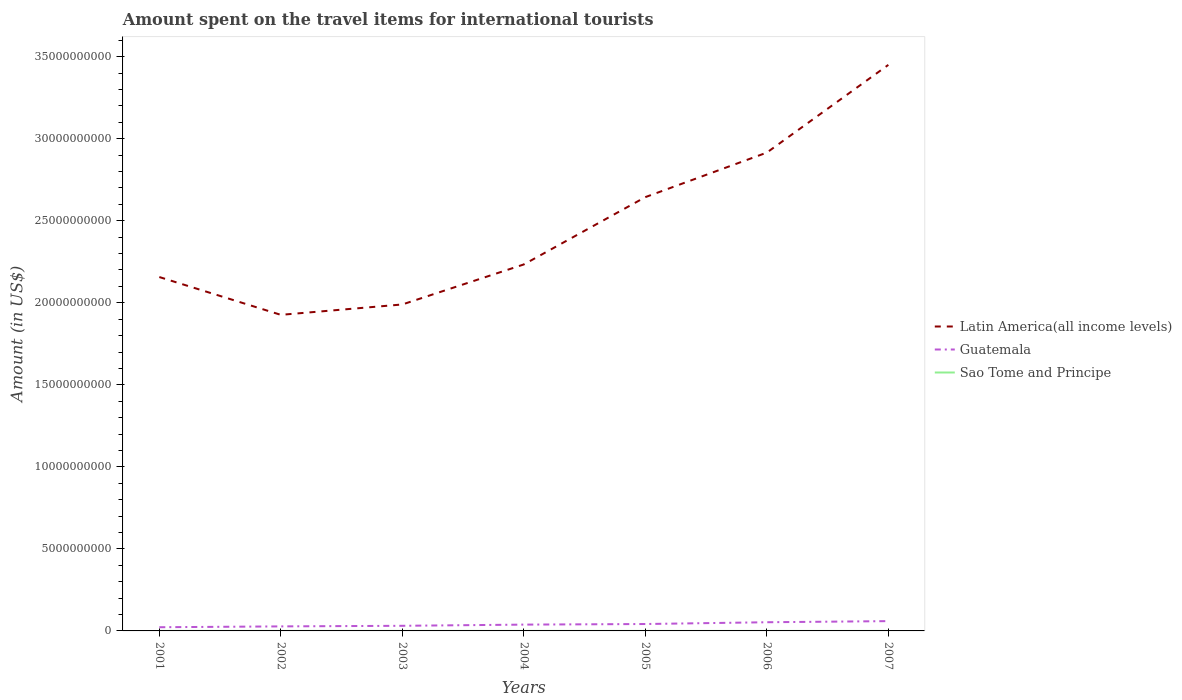Is the number of lines equal to the number of legend labels?
Keep it short and to the point. Yes. Across all years, what is the maximum amount spent on the travel items for international tourists in Latin America(all income levels)?
Your response must be concise. 1.93e+1. In which year was the amount spent on the travel items for international tourists in Guatemala maximum?
Ensure brevity in your answer.  2001. What is the total amount spent on the travel items for international tourists in Latin America(all income levels) in the graph?
Ensure brevity in your answer.  -5.35e+09. What is the difference between the highest and the second highest amount spent on the travel items for international tourists in Latin America(all income levels)?
Provide a short and direct response. 1.52e+1. What is the difference between the highest and the lowest amount spent on the travel items for international tourists in Latin America(all income levels)?
Offer a terse response. 3. How many years are there in the graph?
Offer a terse response. 7. What is the difference between two consecutive major ticks on the Y-axis?
Provide a short and direct response. 5.00e+09. How many legend labels are there?
Give a very brief answer. 3. What is the title of the graph?
Make the answer very short. Amount spent on the travel items for international tourists. What is the label or title of the X-axis?
Keep it short and to the point. Years. What is the Amount (in US$) in Latin America(all income levels) in 2001?
Keep it short and to the point. 2.16e+1. What is the Amount (in US$) of Guatemala in 2001?
Keep it short and to the point. 2.25e+08. What is the Amount (in US$) in Latin America(all income levels) in 2002?
Keep it short and to the point. 1.93e+1. What is the Amount (in US$) of Guatemala in 2002?
Offer a terse response. 2.76e+08. What is the Amount (in US$) of Latin America(all income levels) in 2003?
Provide a short and direct response. 1.99e+1. What is the Amount (in US$) of Guatemala in 2003?
Provide a short and direct response. 3.12e+08. What is the Amount (in US$) of Sao Tome and Principe in 2003?
Offer a very short reply. 5.00e+05. What is the Amount (in US$) in Latin America(all income levels) in 2004?
Provide a succinct answer. 2.23e+1. What is the Amount (in US$) of Guatemala in 2004?
Provide a succinct answer. 3.85e+08. What is the Amount (in US$) of Latin America(all income levels) in 2005?
Offer a very short reply. 2.64e+1. What is the Amount (in US$) in Guatemala in 2005?
Offer a terse response. 4.21e+08. What is the Amount (in US$) of Sao Tome and Principe in 2005?
Your answer should be compact. 5.00e+04. What is the Amount (in US$) of Latin America(all income levels) in 2006?
Give a very brief answer. 2.92e+1. What is the Amount (in US$) in Guatemala in 2006?
Your answer should be very brief. 5.29e+08. What is the Amount (in US$) in Sao Tome and Principe in 2006?
Give a very brief answer. 2.00e+05. What is the Amount (in US$) of Latin America(all income levels) in 2007?
Offer a terse response. 3.45e+1. What is the Amount (in US$) in Guatemala in 2007?
Provide a short and direct response. 5.97e+08. Across all years, what is the maximum Amount (in US$) of Latin America(all income levels)?
Make the answer very short. 3.45e+1. Across all years, what is the maximum Amount (in US$) of Guatemala?
Your answer should be very brief. 5.97e+08. Across all years, what is the minimum Amount (in US$) of Latin America(all income levels)?
Provide a short and direct response. 1.93e+1. Across all years, what is the minimum Amount (in US$) of Guatemala?
Your response must be concise. 2.25e+08. Across all years, what is the minimum Amount (in US$) of Sao Tome and Principe?
Offer a very short reply. 5.00e+04. What is the total Amount (in US$) in Latin America(all income levels) in the graph?
Ensure brevity in your answer.  1.73e+11. What is the total Amount (in US$) of Guatemala in the graph?
Provide a short and direct response. 2.74e+09. What is the total Amount (in US$) of Sao Tome and Principe in the graph?
Keep it short and to the point. 2.55e+06. What is the difference between the Amount (in US$) of Latin America(all income levels) in 2001 and that in 2002?
Ensure brevity in your answer.  2.30e+09. What is the difference between the Amount (in US$) of Guatemala in 2001 and that in 2002?
Your response must be concise. -5.10e+07. What is the difference between the Amount (in US$) in Latin America(all income levels) in 2001 and that in 2003?
Your response must be concise. 1.67e+09. What is the difference between the Amount (in US$) of Guatemala in 2001 and that in 2003?
Your answer should be compact. -8.70e+07. What is the difference between the Amount (in US$) of Sao Tome and Principe in 2001 and that in 2003?
Ensure brevity in your answer.  1.00e+05. What is the difference between the Amount (in US$) of Latin America(all income levels) in 2001 and that in 2004?
Provide a short and direct response. -7.68e+08. What is the difference between the Amount (in US$) in Guatemala in 2001 and that in 2004?
Make the answer very short. -1.60e+08. What is the difference between the Amount (in US$) of Sao Tome and Principe in 2001 and that in 2004?
Ensure brevity in your answer.  0. What is the difference between the Amount (in US$) in Latin America(all income levels) in 2001 and that in 2005?
Make the answer very short. -4.87e+09. What is the difference between the Amount (in US$) in Guatemala in 2001 and that in 2005?
Ensure brevity in your answer.  -1.96e+08. What is the difference between the Amount (in US$) in Sao Tome and Principe in 2001 and that in 2005?
Your answer should be very brief. 5.50e+05. What is the difference between the Amount (in US$) of Latin America(all income levels) in 2001 and that in 2006?
Provide a succinct answer. -7.59e+09. What is the difference between the Amount (in US$) in Guatemala in 2001 and that in 2006?
Your answer should be compact. -3.04e+08. What is the difference between the Amount (in US$) of Latin America(all income levels) in 2001 and that in 2007?
Your answer should be very brief. -1.29e+1. What is the difference between the Amount (in US$) in Guatemala in 2001 and that in 2007?
Give a very brief answer. -3.72e+08. What is the difference between the Amount (in US$) of Sao Tome and Principe in 2001 and that in 2007?
Offer a terse response. 5.00e+05. What is the difference between the Amount (in US$) of Latin America(all income levels) in 2002 and that in 2003?
Your answer should be compact. -6.33e+08. What is the difference between the Amount (in US$) in Guatemala in 2002 and that in 2003?
Ensure brevity in your answer.  -3.60e+07. What is the difference between the Amount (in US$) of Latin America(all income levels) in 2002 and that in 2004?
Offer a terse response. -3.07e+09. What is the difference between the Amount (in US$) in Guatemala in 2002 and that in 2004?
Offer a very short reply. -1.09e+08. What is the difference between the Amount (in US$) in Sao Tome and Principe in 2002 and that in 2004?
Your answer should be very brief. -1.00e+05. What is the difference between the Amount (in US$) of Latin America(all income levels) in 2002 and that in 2005?
Give a very brief answer. -7.17e+09. What is the difference between the Amount (in US$) in Guatemala in 2002 and that in 2005?
Make the answer very short. -1.45e+08. What is the difference between the Amount (in US$) in Sao Tome and Principe in 2002 and that in 2005?
Your answer should be compact. 4.50e+05. What is the difference between the Amount (in US$) of Latin America(all income levels) in 2002 and that in 2006?
Provide a short and direct response. -9.89e+09. What is the difference between the Amount (in US$) in Guatemala in 2002 and that in 2006?
Your answer should be compact. -2.53e+08. What is the difference between the Amount (in US$) in Latin America(all income levels) in 2002 and that in 2007?
Make the answer very short. -1.52e+1. What is the difference between the Amount (in US$) in Guatemala in 2002 and that in 2007?
Make the answer very short. -3.21e+08. What is the difference between the Amount (in US$) in Latin America(all income levels) in 2003 and that in 2004?
Offer a very short reply. -2.44e+09. What is the difference between the Amount (in US$) of Guatemala in 2003 and that in 2004?
Give a very brief answer. -7.30e+07. What is the difference between the Amount (in US$) of Latin America(all income levels) in 2003 and that in 2005?
Ensure brevity in your answer.  -6.54e+09. What is the difference between the Amount (in US$) in Guatemala in 2003 and that in 2005?
Your response must be concise. -1.09e+08. What is the difference between the Amount (in US$) of Latin America(all income levels) in 2003 and that in 2006?
Give a very brief answer. -9.26e+09. What is the difference between the Amount (in US$) in Guatemala in 2003 and that in 2006?
Provide a short and direct response. -2.17e+08. What is the difference between the Amount (in US$) in Sao Tome and Principe in 2003 and that in 2006?
Ensure brevity in your answer.  3.00e+05. What is the difference between the Amount (in US$) in Latin America(all income levels) in 2003 and that in 2007?
Keep it short and to the point. -1.46e+1. What is the difference between the Amount (in US$) of Guatemala in 2003 and that in 2007?
Provide a short and direct response. -2.85e+08. What is the difference between the Amount (in US$) of Sao Tome and Principe in 2003 and that in 2007?
Keep it short and to the point. 4.00e+05. What is the difference between the Amount (in US$) in Latin America(all income levels) in 2004 and that in 2005?
Ensure brevity in your answer.  -4.10e+09. What is the difference between the Amount (in US$) of Guatemala in 2004 and that in 2005?
Give a very brief answer. -3.60e+07. What is the difference between the Amount (in US$) of Sao Tome and Principe in 2004 and that in 2005?
Ensure brevity in your answer.  5.50e+05. What is the difference between the Amount (in US$) of Latin America(all income levels) in 2004 and that in 2006?
Provide a succinct answer. -6.82e+09. What is the difference between the Amount (in US$) in Guatemala in 2004 and that in 2006?
Your response must be concise. -1.44e+08. What is the difference between the Amount (in US$) of Sao Tome and Principe in 2004 and that in 2006?
Keep it short and to the point. 4.00e+05. What is the difference between the Amount (in US$) of Latin America(all income levels) in 2004 and that in 2007?
Your response must be concise. -1.22e+1. What is the difference between the Amount (in US$) in Guatemala in 2004 and that in 2007?
Your answer should be very brief. -2.12e+08. What is the difference between the Amount (in US$) in Latin America(all income levels) in 2005 and that in 2006?
Your answer should be very brief. -2.71e+09. What is the difference between the Amount (in US$) in Guatemala in 2005 and that in 2006?
Provide a succinct answer. -1.08e+08. What is the difference between the Amount (in US$) of Sao Tome and Principe in 2005 and that in 2006?
Provide a short and direct response. -1.50e+05. What is the difference between the Amount (in US$) of Latin America(all income levels) in 2005 and that in 2007?
Your answer should be very brief. -8.06e+09. What is the difference between the Amount (in US$) in Guatemala in 2005 and that in 2007?
Offer a terse response. -1.76e+08. What is the difference between the Amount (in US$) in Latin America(all income levels) in 2006 and that in 2007?
Ensure brevity in your answer.  -5.35e+09. What is the difference between the Amount (in US$) of Guatemala in 2006 and that in 2007?
Make the answer very short. -6.80e+07. What is the difference between the Amount (in US$) in Latin America(all income levels) in 2001 and the Amount (in US$) in Guatemala in 2002?
Offer a terse response. 2.13e+1. What is the difference between the Amount (in US$) in Latin America(all income levels) in 2001 and the Amount (in US$) in Sao Tome and Principe in 2002?
Keep it short and to the point. 2.16e+1. What is the difference between the Amount (in US$) of Guatemala in 2001 and the Amount (in US$) of Sao Tome and Principe in 2002?
Keep it short and to the point. 2.24e+08. What is the difference between the Amount (in US$) in Latin America(all income levels) in 2001 and the Amount (in US$) in Guatemala in 2003?
Provide a short and direct response. 2.13e+1. What is the difference between the Amount (in US$) of Latin America(all income levels) in 2001 and the Amount (in US$) of Sao Tome and Principe in 2003?
Make the answer very short. 2.16e+1. What is the difference between the Amount (in US$) in Guatemala in 2001 and the Amount (in US$) in Sao Tome and Principe in 2003?
Ensure brevity in your answer.  2.24e+08. What is the difference between the Amount (in US$) of Latin America(all income levels) in 2001 and the Amount (in US$) of Guatemala in 2004?
Your response must be concise. 2.12e+1. What is the difference between the Amount (in US$) in Latin America(all income levels) in 2001 and the Amount (in US$) in Sao Tome and Principe in 2004?
Ensure brevity in your answer.  2.16e+1. What is the difference between the Amount (in US$) in Guatemala in 2001 and the Amount (in US$) in Sao Tome and Principe in 2004?
Keep it short and to the point. 2.24e+08. What is the difference between the Amount (in US$) of Latin America(all income levels) in 2001 and the Amount (in US$) of Guatemala in 2005?
Give a very brief answer. 2.11e+1. What is the difference between the Amount (in US$) in Latin America(all income levels) in 2001 and the Amount (in US$) in Sao Tome and Principe in 2005?
Offer a very short reply. 2.16e+1. What is the difference between the Amount (in US$) in Guatemala in 2001 and the Amount (in US$) in Sao Tome and Principe in 2005?
Your response must be concise. 2.25e+08. What is the difference between the Amount (in US$) in Latin America(all income levels) in 2001 and the Amount (in US$) in Guatemala in 2006?
Keep it short and to the point. 2.10e+1. What is the difference between the Amount (in US$) in Latin America(all income levels) in 2001 and the Amount (in US$) in Sao Tome and Principe in 2006?
Make the answer very short. 2.16e+1. What is the difference between the Amount (in US$) of Guatemala in 2001 and the Amount (in US$) of Sao Tome and Principe in 2006?
Provide a short and direct response. 2.25e+08. What is the difference between the Amount (in US$) of Latin America(all income levels) in 2001 and the Amount (in US$) of Guatemala in 2007?
Keep it short and to the point. 2.10e+1. What is the difference between the Amount (in US$) of Latin America(all income levels) in 2001 and the Amount (in US$) of Sao Tome and Principe in 2007?
Provide a succinct answer. 2.16e+1. What is the difference between the Amount (in US$) in Guatemala in 2001 and the Amount (in US$) in Sao Tome and Principe in 2007?
Offer a very short reply. 2.25e+08. What is the difference between the Amount (in US$) of Latin America(all income levels) in 2002 and the Amount (in US$) of Guatemala in 2003?
Provide a short and direct response. 1.90e+1. What is the difference between the Amount (in US$) in Latin America(all income levels) in 2002 and the Amount (in US$) in Sao Tome and Principe in 2003?
Keep it short and to the point. 1.93e+1. What is the difference between the Amount (in US$) of Guatemala in 2002 and the Amount (in US$) of Sao Tome and Principe in 2003?
Your answer should be very brief. 2.76e+08. What is the difference between the Amount (in US$) in Latin America(all income levels) in 2002 and the Amount (in US$) in Guatemala in 2004?
Keep it short and to the point. 1.89e+1. What is the difference between the Amount (in US$) of Latin America(all income levels) in 2002 and the Amount (in US$) of Sao Tome and Principe in 2004?
Give a very brief answer. 1.93e+1. What is the difference between the Amount (in US$) of Guatemala in 2002 and the Amount (in US$) of Sao Tome and Principe in 2004?
Offer a very short reply. 2.75e+08. What is the difference between the Amount (in US$) of Latin America(all income levels) in 2002 and the Amount (in US$) of Guatemala in 2005?
Ensure brevity in your answer.  1.88e+1. What is the difference between the Amount (in US$) in Latin America(all income levels) in 2002 and the Amount (in US$) in Sao Tome and Principe in 2005?
Your answer should be very brief. 1.93e+1. What is the difference between the Amount (in US$) in Guatemala in 2002 and the Amount (in US$) in Sao Tome and Principe in 2005?
Offer a very short reply. 2.76e+08. What is the difference between the Amount (in US$) in Latin America(all income levels) in 2002 and the Amount (in US$) in Guatemala in 2006?
Offer a very short reply. 1.87e+1. What is the difference between the Amount (in US$) of Latin America(all income levels) in 2002 and the Amount (in US$) of Sao Tome and Principe in 2006?
Ensure brevity in your answer.  1.93e+1. What is the difference between the Amount (in US$) of Guatemala in 2002 and the Amount (in US$) of Sao Tome and Principe in 2006?
Offer a very short reply. 2.76e+08. What is the difference between the Amount (in US$) of Latin America(all income levels) in 2002 and the Amount (in US$) of Guatemala in 2007?
Ensure brevity in your answer.  1.87e+1. What is the difference between the Amount (in US$) of Latin America(all income levels) in 2002 and the Amount (in US$) of Sao Tome and Principe in 2007?
Ensure brevity in your answer.  1.93e+1. What is the difference between the Amount (in US$) in Guatemala in 2002 and the Amount (in US$) in Sao Tome and Principe in 2007?
Make the answer very short. 2.76e+08. What is the difference between the Amount (in US$) of Latin America(all income levels) in 2003 and the Amount (in US$) of Guatemala in 2004?
Provide a succinct answer. 1.95e+1. What is the difference between the Amount (in US$) in Latin America(all income levels) in 2003 and the Amount (in US$) in Sao Tome and Principe in 2004?
Keep it short and to the point. 1.99e+1. What is the difference between the Amount (in US$) of Guatemala in 2003 and the Amount (in US$) of Sao Tome and Principe in 2004?
Provide a succinct answer. 3.11e+08. What is the difference between the Amount (in US$) of Latin America(all income levels) in 2003 and the Amount (in US$) of Guatemala in 2005?
Ensure brevity in your answer.  1.95e+1. What is the difference between the Amount (in US$) in Latin America(all income levels) in 2003 and the Amount (in US$) in Sao Tome and Principe in 2005?
Ensure brevity in your answer.  1.99e+1. What is the difference between the Amount (in US$) in Guatemala in 2003 and the Amount (in US$) in Sao Tome and Principe in 2005?
Ensure brevity in your answer.  3.12e+08. What is the difference between the Amount (in US$) of Latin America(all income levels) in 2003 and the Amount (in US$) of Guatemala in 2006?
Ensure brevity in your answer.  1.94e+1. What is the difference between the Amount (in US$) of Latin America(all income levels) in 2003 and the Amount (in US$) of Sao Tome and Principe in 2006?
Ensure brevity in your answer.  1.99e+1. What is the difference between the Amount (in US$) in Guatemala in 2003 and the Amount (in US$) in Sao Tome and Principe in 2006?
Make the answer very short. 3.12e+08. What is the difference between the Amount (in US$) of Latin America(all income levels) in 2003 and the Amount (in US$) of Guatemala in 2007?
Provide a succinct answer. 1.93e+1. What is the difference between the Amount (in US$) of Latin America(all income levels) in 2003 and the Amount (in US$) of Sao Tome and Principe in 2007?
Make the answer very short. 1.99e+1. What is the difference between the Amount (in US$) in Guatemala in 2003 and the Amount (in US$) in Sao Tome and Principe in 2007?
Keep it short and to the point. 3.12e+08. What is the difference between the Amount (in US$) of Latin America(all income levels) in 2004 and the Amount (in US$) of Guatemala in 2005?
Make the answer very short. 2.19e+1. What is the difference between the Amount (in US$) in Latin America(all income levels) in 2004 and the Amount (in US$) in Sao Tome and Principe in 2005?
Offer a very short reply. 2.23e+1. What is the difference between the Amount (in US$) in Guatemala in 2004 and the Amount (in US$) in Sao Tome and Principe in 2005?
Your answer should be compact. 3.85e+08. What is the difference between the Amount (in US$) in Latin America(all income levels) in 2004 and the Amount (in US$) in Guatemala in 2006?
Make the answer very short. 2.18e+1. What is the difference between the Amount (in US$) of Latin America(all income levels) in 2004 and the Amount (in US$) of Sao Tome and Principe in 2006?
Offer a terse response. 2.23e+1. What is the difference between the Amount (in US$) in Guatemala in 2004 and the Amount (in US$) in Sao Tome and Principe in 2006?
Your answer should be compact. 3.85e+08. What is the difference between the Amount (in US$) in Latin America(all income levels) in 2004 and the Amount (in US$) in Guatemala in 2007?
Keep it short and to the point. 2.17e+1. What is the difference between the Amount (in US$) of Latin America(all income levels) in 2004 and the Amount (in US$) of Sao Tome and Principe in 2007?
Make the answer very short. 2.23e+1. What is the difference between the Amount (in US$) in Guatemala in 2004 and the Amount (in US$) in Sao Tome and Principe in 2007?
Keep it short and to the point. 3.85e+08. What is the difference between the Amount (in US$) in Latin America(all income levels) in 2005 and the Amount (in US$) in Guatemala in 2006?
Your answer should be compact. 2.59e+1. What is the difference between the Amount (in US$) of Latin America(all income levels) in 2005 and the Amount (in US$) of Sao Tome and Principe in 2006?
Provide a succinct answer. 2.64e+1. What is the difference between the Amount (in US$) of Guatemala in 2005 and the Amount (in US$) of Sao Tome and Principe in 2006?
Ensure brevity in your answer.  4.21e+08. What is the difference between the Amount (in US$) of Latin America(all income levels) in 2005 and the Amount (in US$) of Guatemala in 2007?
Your response must be concise. 2.58e+1. What is the difference between the Amount (in US$) in Latin America(all income levels) in 2005 and the Amount (in US$) in Sao Tome and Principe in 2007?
Your answer should be very brief. 2.64e+1. What is the difference between the Amount (in US$) of Guatemala in 2005 and the Amount (in US$) of Sao Tome and Principe in 2007?
Make the answer very short. 4.21e+08. What is the difference between the Amount (in US$) in Latin America(all income levels) in 2006 and the Amount (in US$) in Guatemala in 2007?
Provide a succinct answer. 2.86e+1. What is the difference between the Amount (in US$) in Latin America(all income levels) in 2006 and the Amount (in US$) in Sao Tome and Principe in 2007?
Keep it short and to the point. 2.92e+1. What is the difference between the Amount (in US$) in Guatemala in 2006 and the Amount (in US$) in Sao Tome and Principe in 2007?
Provide a succinct answer. 5.29e+08. What is the average Amount (in US$) in Latin America(all income levels) per year?
Offer a terse response. 2.47e+1. What is the average Amount (in US$) of Guatemala per year?
Offer a terse response. 3.92e+08. What is the average Amount (in US$) of Sao Tome and Principe per year?
Your response must be concise. 3.64e+05. In the year 2001, what is the difference between the Amount (in US$) of Latin America(all income levels) and Amount (in US$) of Guatemala?
Make the answer very short. 2.13e+1. In the year 2001, what is the difference between the Amount (in US$) of Latin America(all income levels) and Amount (in US$) of Sao Tome and Principe?
Give a very brief answer. 2.16e+1. In the year 2001, what is the difference between the Amount (in US$) of Guatemala and Amount (in US$) of Sao Tome and Principe?
Your answer should be compact. 2.24e+08. In the year 2002, what is the difference between the Amount (in US$) of Latin America(all income levels) and Amount (in US$) of Guatemala?
Keep it short and to the point. 1.90e+1. In the year 2002, what is the difference between the Amount (in US$) in Latin America(all income levels) and Amount (in US$) in Sao Tome and Principe?
Your response must be concise. 1.93e+1. In the year 2002, what is the difference between the Amount (in US$) in Guatemala and Amount (in US$) in Sao Tome and Principe?
Offer a very short reply. 2.76e+08. In the year 2003, what is the difference between the Amount (in US$) in Latin America(all income levels) and Amount (in US$) in Guatemala?
Your answer should be very brief. 1.96e+1. In the year 2003, what is the difference between the Amount (in US$) of Latin America(all income levels) and Amount (in US$) of Sao Tome and Principe?
Ensure brevity in your answer.  1.99e+1. In the year 2003, what is the difference between the Amount (in US$) of Guatemala and Amount (in US$) of Sao Tome and Principe?
Your answer should be compact. 3.12e+08. In the year 2004, what is the difference between the Amount (in US$) in Latin America(all income levels) and Amount (in US$) in Guatemala?
Give a very brief answer. 2.20e+1. In the year 2004, what is the difference between the Amount (in US$) in Latin America(all income levels) and Amount (in US$) in Sao Tome and Principe?
Give a very brief answer. 2.23e+1. In the year 2004, what is the difference between the Amount (in US$) of Guatemala and Amount (in US$) of Sao Tome and Principe?
Your response must be concise. 3.84e+08. In the year 2005, what is the difference between the Amount (in US$) in Latin America(all income levels) and Amount (in US$) in Guatemala?
Make the answer very short. 2.60e+1. In the year 2005, what is the difference between the Amount (in US$) of Latin America(all income levels) and Amount (in US$) of Sao Tome and Principe?
Keep it short and to the point. 2.64e+1. In the year 2005, what is the difference between the Amount (in US$) in Guatemala and Amount (in US$) in Sao Tome and Principe?
Give a very brief answer. 4.21e+08. In the year 2006, what is the difference between the Amount (in US$) in Latin America(all income levels) and Amount (in US$) in Guatemala?
Give a very brief answer. 2.86e+1. In the year 2006, what is the difference between the Amount (in US$) in Latin America(all income levels) and Amount (in US$) in Sao Tome and Principe?
Your answer should be compact. 2.92e+1. In the year 2006, what is the difference between the Amount (in US$) of Guatemala and Amount (in US$) of Sao Tome and Principe?
Your answer should be compact. 5.29e+08. In the year 2007, what is the difference between the Amount (in US$) of Latin America(all income levels) and Amount (in US$) of Guatemala?
Give a very brief answer. 3.39e+1. In the year 2007, what is the difference between the Amount (in US$) in Latin America(all income levels) and Amount (in US$) in Sao Tome and Principe?
Provide a short and direct response. 3.45e+1. In the year 2007, what is the difference between the Amount (in US$) in Guatemala and Amount (in US$) in Sao Tome and Principe?
Give a very brief answer. 5.97e+08. What is the ratio of the Amount (in US$) of Latin America(all income levels) in 2001 to that in 2002?
Offer a terse response. 1.12. What is the ratio of the Amount (in US$) in Guatemala in 2001 to that in 2002?
Keep it short and to the point. 0.82. What is the ratio of the Amount (in US$) in Latin America(all income levels) in 2001 to that in 2003?
Ensure brevity in your answer.  1.08. What is the ratio of the Amount (in US$) of Guatemala in 2001 to that in 2003?
Your answer should be compact. 0.72. What is the ratio of the Amount (in US$) of Latin America(all income levels) in 2001 to that in 2004?
Your answer should be compact. 0.97. What is the ratio of the Amount (in US$) of Guatemala in 2001 to that in 2004?
Your response must be concise. 0.58. What is the ratio of the Amount (in US$) in Latin America(all income levels) in 2001 to that in 2005?
Your answer should be compact. 0.82. What is the ratio of the Amount (in US$) in Guatemala in 2001 to that in 2005?
Give a very brief answer. 0.53. What is the ratio of the Amount (in US$) in Sao Tome and Principe in 2001 to that in 2005?
Your answer should be very brief. 12. What is the ratio of the Amount (in US$) of Latin America(all income levels) in 2001 to that in 2006?
Make the answer very short. 0.74. What is the ratio of the Amount (in US$) of Guatemala in 2001 to that in 2006?
Your response must be concise. 0.43. What is the ratio of the Amount (in US$) in Sao Tome and Principe in 2001 to that in 2006?
Your answer should be very brief. 3. What is the ratio of the Amount (in US$) of Latin America(all income levels) in 2001 to that in 2007?
Your answer should be compact. 0.63. What is the ratio of the Amount (in US$) of Guatemala in 2001 to that in 2007?
Provide a succinct answer. 0.38. What is the ratio of the Amount (in US$) of Latin America(all income levels) in 2002 to that in 2003?
Your answer should be compact. 0.97. What is the ratio of the Amount (in US$) of Guatemala in 2002 to that in 2003?
Ensure brevity in your answer.  0.88. What is the ratio of the Amount (in US$) in Sao Tome and Principe in 2002 to that in 2003?
Your answer should be compact. 1. What is the ratio of the Amount (in US$) in Latin America(all income levels) in 2002 to that in 2004?
Ensure brevity in your answer.  0.86. What is the ratio of the Amount (in US$) of Guatemala in 2002 to that in 2004?
Your answer should be compact. 0.72. What is the ratio of the Amount (in US$) of Sao Tome and Principe in 2002 to that in 2004?
Ensure brevity in your answer.  0.83. What is the ratio of the Amount (in US$) of Latin America(all income levels) in 2002 to that in 2005?
Offer a terse response. 0.73. What is the ratio of the Amount (in US$) of Guatemala in 2002 to that in 2005?
Your response must be concise. 0.66. What is the ratio of the Amount (in US$) in Sao Tome and Principe in 2002 to that in 2005?
Provide a short and direct response. 10. What is the ratio of the Amount (in US$) in Latin America(all income levels) in 2002 to that in 2006?
Give a very brief answer. 0.66. What is the ratio of the Amount (in US$) in Guatemala in 2002 to that in 2006?
Give a very brief answer. 0.52. What is the ratio of the Amount (in US$) in Sao Tome and Principe in 2002 to that in 2006?
Your answer should be compact. 2.5. What is the ratio of the Amount (in US$) in Latin America(all income levels) in 2002 to that in 2007?
Provide a succinct answer. 0.56. What is the ratio of the Amount (in US$) in Guatemala in 2002 to that in 2007?
Provide a short and direct response. 0.46. What is the ratio of the Amount (in US$) in Latin America(all income levels) in 2003 to that in 2004?
Give a very brief answer. 0.89. What is the ratio of the Amount (in US$) of Guatemala in 2003 to that in 2004?
Keep it short and to the point. 0.81. What is the ratio of the Amount (in US$) of Latin America(all income levels) in 2003 to that in 2005?
Give a very brief answer. 0.75. What is the ratio of the Amount (in US$) in Guatemala in 2003 to that in 2005?
Your answer should be compact. 0.74. What is the ratio of the Amount (in US$) in Sao Tome and Principe in 2003 to that in 2005?
Make the answer very short. 10. What is the ratio of the Amount (in US$) of Latin America(all income levels) in 2003 to that in 2006?
Make the answer very short. 0.68. What is the ratio of the Amount (in US$) in Guatemala in 2003 to that in 2006?
Your answer should be very brief. 0.59. What is the ratio of the Amount (in US$) in Latin America(all income levels) in 2003 to that in 2007?
Your response must be concise. 0.58. What is the ratio of the Amount (in US$) of Guatemala in 2003 to that in 2007?
Your answer should be compact. 0.52. What is the ratio of the Amount (in US$) in Latin America(all income levels) in 2004 to that in 2005?
Provide a succinct answer. 0.84. What is the ratio of the Amount (in US$) in Guatemala in 2004 to that in 2005?
Your answer should be very brief. 0.91. What is the ratio of the Amount (in US$) in Latin America(all income levels) in 2004 to that in 2006?
Provide a short and direct response. 0.77. What is the ratio of the Amount (in US$) of Guatemala in 2004 to that in 2006?
Keep it short and to the point. 0.73. What is the ratio of the Amount (in US$) of Latin America(all income levels) in 2004 to that in 2007?
Your answer should be compact. 0.65. What is the ratio of the Amount (in US$) of Guatemala in 2004 to that in 2007?
Your response must be concise. 0.64. What is the ratio of the Amount (in US$) of Latin America(all income levels) in 2005 to that in 2006?
Your answer should be very brief. 0.91. What is the ratio of the Amount (in US$) of Guatemala in 2005 to that in 2006?
Your answer should be very brief. 0.8. What is the ratio of the Amount (in US$) of Latin America(all income levels) in 2005 to that in 2007?
Keep it short and to the point. 0.77. What is the ratio of the Amount (in US$) in Guatemala in 2005 to that in 2007?
Make the answer very short. 0.71. What is the ratio of the Amount (in US$) of Latin America(all income levels) in 2006 to that in 2007?
Your answer should be compact. 0.84. What is the ratio of the Amount (in US$) in Guatemala in 2006 to that in 2007?
Offer a very short reply. 0.89. What is the ratio of the Amount (in US$) in Sao Tome and Principe in 2006 to that in 2007?
Give a very brief answer. 2. What is the difference between the highest and the second highest Amount (in US$) of Latin America(all income levels)?
Your answer should be compact. 5.35e+09. What is the difference between the highest and the second highest Amount (in US$) in Guatemala?
Your answer should be very brief. 6.80e+07. What is the difference between the highest and the lowest Amount (in US$) of Latin America(all income levels)?
Give a very brief answer. 1.52e+1. What is the difference between the highest and the lowest Amount (in US$) in Guatemala?
Give a very brief answer. 3.72e+08. 